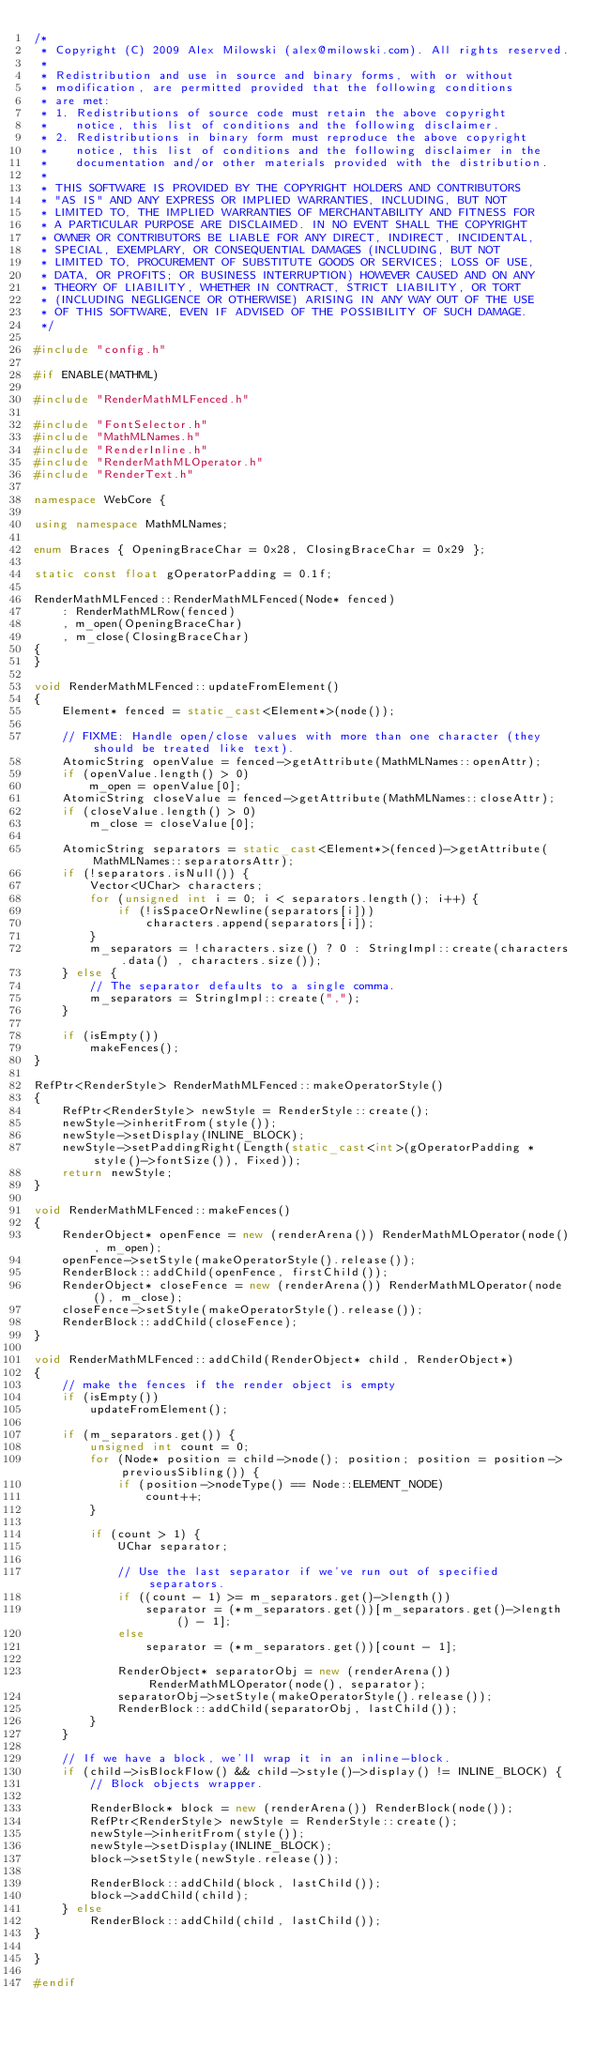<code> <loc_0><loc_0><loc_500><loc_500><_C++_>/*
 * Copyright (C) 2009 Alex Milowski (alex@milowski.com). All rights reserved.
 *
 * Redistribution and use in source and binary forms, with or without
 * modification, are permitted provided that the following conditions
 * are met:
 * 1. Redistributions of source code must retain the above copyright
 *    notice, this list of conditions and the following disclaimer.
 * 2. Redistributions in binary form must reproduce the above copyright
 *    notice, this list of conditions and the following disclaimer in the
 *    documentation and/or other materials provided with the distribution.
 *
 * THIS SOFTWARE IS PROVIDED BY THE COPYRIGHT HOLDERS AND CONTRIBUTORS
 * "AS IS" AND ANY EXPRESS OR IMPLIED WARRANTIES, INCLUDING, BUT NOT
 * LIMITED TO, THE IMPLIED WARRANTIES OF MERCHANTABILITY AND FITNESS FOR
 * A PARTICULAR PURPOSE ARE DISCLAIMED. IN NO EVENT SHALL THE COPYRIGHT
 * OWNER OR CONTRIBUTORS BE LIABLE FOR ANY DIRECT, INDIRECT, INCIDENTAL,
 * SPECIAL, EXEMPLARY, OR CONSEQUENTIAL DAMAGES (INCLUDING, BUT NOT
 * LIMITED TO, PROCUREMENT OF SUBSTITUTE GOODS OR SERVICES; LOSS OF USE,
 * DATA, OR PROFITS; OR BUSINESS INTERRUPTION) HOWEVER CAUSED AND ON ANY
 * THEORY OF LIABILITY, WHETHER IN CONTRACT, STRICT LIABILITY, OR TORT
 * (INCLUDING NEGLIGENCE OR OTHERWISE) ARISING IN ANY WAY OUT OF THE USE
 * OF THIS SOFTWARE, EVEN IF ADVISED OF THE POSSIBILITY OF SUCH DAMAGE.
 */

#include "config.h"

#if ENABLE(MATHML)

#include "RenderMathMLFenced.h"

#include "FontSelector.h"
#include "MathMLNames.h"
#include "RenderInline.h"
#include "RenderMathMLOperator.h"
#include "RenderText.h"

namespace WebCore {
    
using namespace MathMLNames;
    
enum Braces { OpeningBraceChar = 0x28, ClosingBraceChar = 0x29 };
    
static const float gOperatorPadding = 0.1f;

RenderMathMLFenced::RenderMathMLFenced(Node* fenced) 
    : RenderMathMLRow(fenced)
    , m_open(OpeningBraceChar)
    , m_close(ClosingBraceChar)
{
}

void RenderMathMLFenced::updateFromElement()
{
    Element* fenced = static_cast<Element*>(node());
 
    // FIXME: Handle open/close values with more than one character (they should be treated like text).
    AtomicString openValue = fenced->getAttribute(MathMLNames::openAttr);
    if (openValue.length() > 0)
        m_open = openValue[0];
    AtomicString closeValue = fenced->getAttribute(MathMLNames::closeAttr);
    if (closeValue.length() > 0)
        m_close = closeValue[0];
    
    AtomicString separators = static_cast<Element*>(fenced)->getAttribute(MathMLNames::separatorsAttr);
    if (!separators.isNull()) {
        Vector<UChar> characters;
        for (unsigned int i = 0; i < separators.length(); i++) {
            if (!isSpaceOrNewline(separators[i]))
                characters.append(separators[i]);
        }
        m_separators = !characters.size() ? 0 : StringImpl::create(characters.data() , characters.size());
    } else {
        // The separator defaults to a single comma.
        m_separators = StringImpl::create(",");
    }
    
    if (isEmpty())
        makeFences();
}

RefPtr<RenderStyle> RenderMathMLFenced::makeOperatorStyle() 
{
    RefPtr<RenderStyle> newStyle = RenderStyle::create();
    newStyle->inheritFrom(style());
    newStyle->setDisplay(INLINE_BLOCK);
    newStyle->setPaddingRight(Length(static_cast<int>(gOperatorPadding * style()->fontSize()), Fixed));
    return newStyle;
}

void RenderMathMLFenced::makeFences()
{
    RenderObject* openFence = new (renderArena()) RenderMathMLOperator(node(), m_open);
    openFence->setStyle(makeOperatorStyle().release());
    RenderBlock::addChild(openFence, firstChild());
    RenderObject* closeFence = new (renderArena()) RenderMathMLOperator(node(), m_close);
    closeFence->setStyle(makeOperatorStyle().release());
    RenderBlock::addChild(closeFence);
}

void RenderMathMLFenced::addChild(RenderObject* child, RenderObject*)
{
    // make the fences if the render object is empty
    if (isEmpty())
        updateFromElement();
    
    if (m_separators.get()) {
        unsigned int count = 0;
        for (Node* position = child->node(); position; position = position->previousSibling()) {
            if (position->nodeType() == Node::ELEMENT_NODE)
                count++;
        }
                
        if (count > 1) {
            UChar separator;
            
            // Use the last separator if we've run out of specified separators.
            if ((count - 1) >= m_separators.get()->length())
                separator = (*m_separators.get())[m_separators.get()->length() - 1];
            else
                separator = (*m_separators.get())[count - 1];
                
            RenderObject* separatorObj = new (renderArena()) RenderMathMLOperator(node(), separator);
            separatorObj->setStyle(makeOperatorStyle().release());
            RenderBlock::addChild(separatorObj, lastChild());
        }
    }
    
    // If we have a block, we'll wrap it in an inline-block.
    if (child->isBlockFlow() && child->style()->display() != INLINE_BLOCK) {
        // Block objects wrapper.

        RenderBlock* block = new (renderArena()) RenderBlock(node());
        RefPtr<RenderStyle> newStyle = RenderStyle::create();
        newStyle->inheritFrom(style());
        newStyle->setDisplay(INLINE_BLOCK);
        block->setStyle(newStyle.release());
        
        RenderBlock::addChild(block, lastChild());
        block->addChild(child);    
    } else
        RenderBlock::addChild(child, lastChild());
}

}    

#endif
</code> 